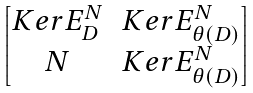Convert formula to latex. <formula><loc_0><loc_0><loc_500><loc_500>\begin{bmatrix} K e r E _ { D } ^ { N } & K e r E _ { \theta ( D ) } ^ { N } \\ N & K e r E _ { \theta ( D ) } ^ { N } \end{bmatrix}</formula> 